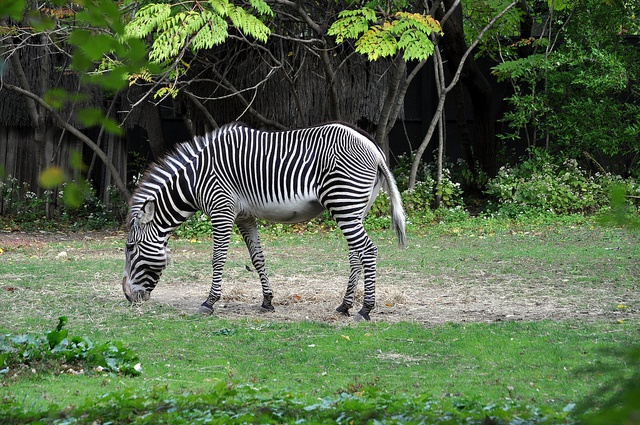Describe the objects in this image and their specific colors. I can see a zebra in darkgreen, black, lightgray, gray, and darkgray tones in this image. 